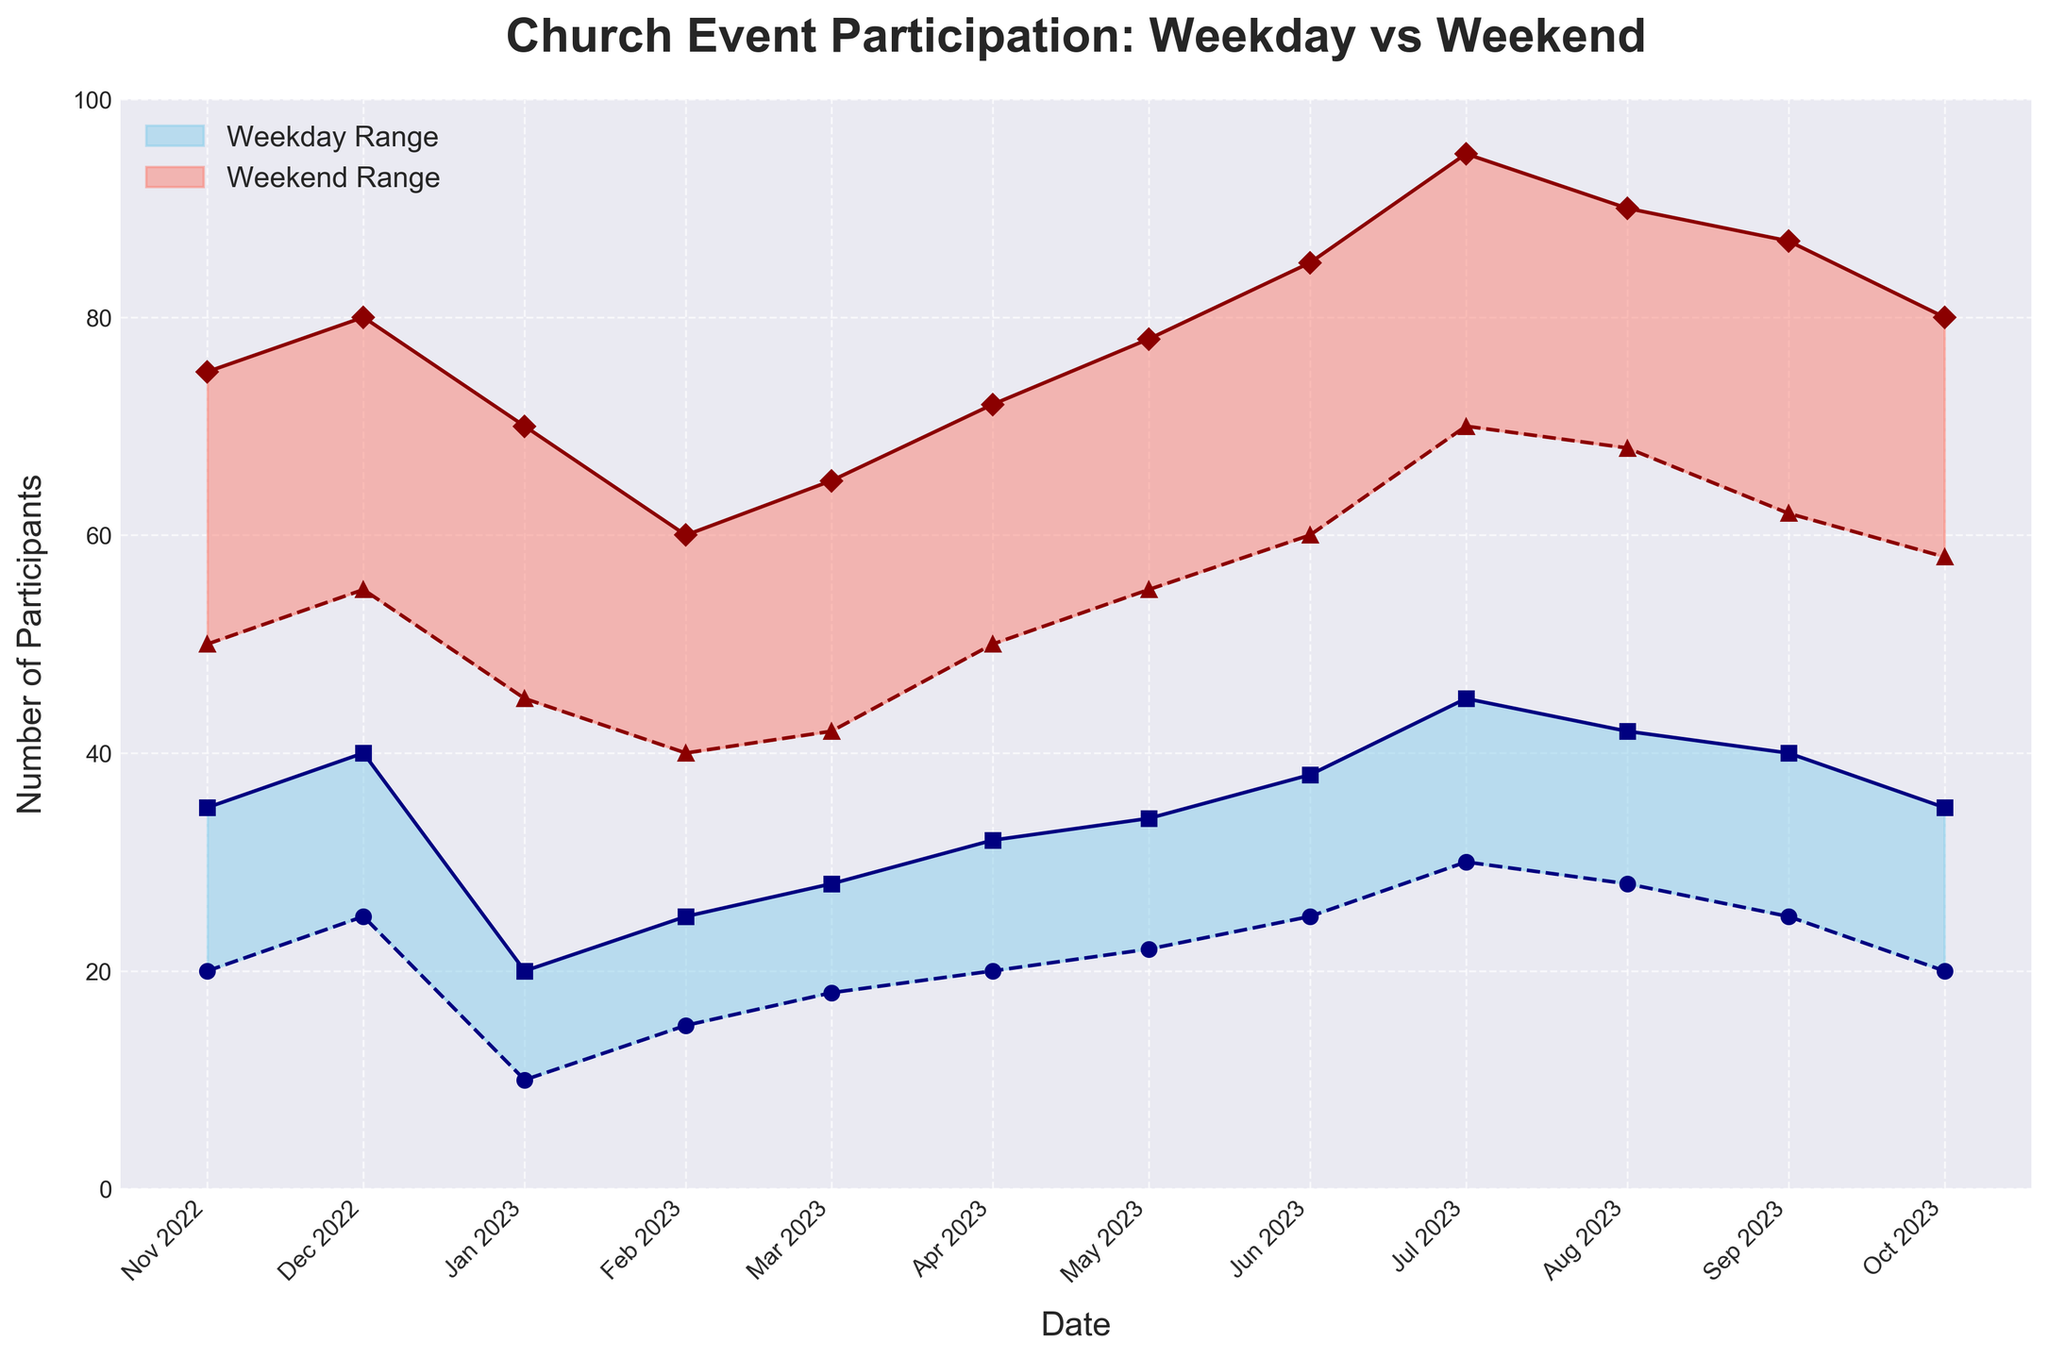What is the title of the chart? The title of the chart is located at the top and it reads 'Church Event Participation: Weekday vs Weekend'.
Answer: Church Event Participation: Weekday vs Weekend How many months of data are displayed in the chart? The x-axis has tick marks for each month from November 2022 to October 2023, so there are 12 months of data shown.
Answer: 12 In which month was the maximum weekend participation observed? To find the highest weekend participation, look for the peak in the topmost red shaded area. The highest peak is in July 2023.
Answer: July 2023 Which month shows the lowest minimum participation for weekday events? Look at the bottom line of the blue shaded area. The lowest point is in January 2023 for weekday participation.
Answer: January 2023 By how much did the maximum weekend participation increase from February to July 2023? Compare the highest point in the red shaded area for February (60) and July (95). The difference is 95 - 60.
Answer: 35 What is the average maximum participation for weekday events over the year? Sum the maximum weekday participation values (35+40+20+25+28+32+34+38+45+42+40+35) and divide by 12. The total is 414, and the average is 414/12.
Answer: 34.5 Which period shows a greater range of participation, weekdays or weekends? Compare the height of the blue and red bands. The red band (weekends) is taller in most instances, suggesting a greater range of participation.
Answer: Weekends Between which months did the minimum weekend participation remain constant? Look at the bottom line of the red shaded area. It stays constant at 55 from December 2022 to January 2023.
Answer: December 2022 to January 2023 Is there any month where the minimum weekend participation was greater than the maximum weekday participation? Compare the lines representing minimum weekend participation and maximum weekday participation. In every month, the minimum weekend participation is higher than the maximum weekday participation.
Answer: Yes What is the trend in participation observed for both weekdays and weekends from November 2022 to October 2023? Observe the general direction of the shaded areas. Both the blue and red shaded areas show an increasing trend from November 2022 to July 2023, then plateauing or decreasing slightly.
Answer: Increasing trend till July, then plateau/decrease 